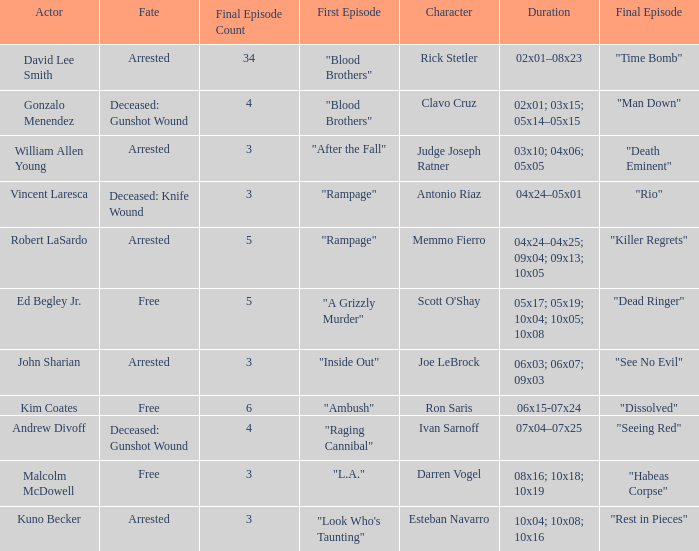Write the full table. {'header': ['Actor', 'Fate', 'Final Episode Count', 'First Episode', 'Character', 'Duration', 'Final Episode'], 'rows': [['David Lee Smith', 'Arrested', '34', '"Blood Brothers"', 'Rick Stetler', '02x01–08x23', '"Time Bomb"'], ['Gonzalo Menendez', 'Deceased: Gunshot Wound', '4', '"Blood Brothers"', 'Clavo Cruz', '02x01; 03x15; 05x14–05x15', '"Man Down"'], ['William Allen Young', 'Arrested', '3', '"After the Fall"', 'Judge Joseph Ratner', '03x10; 04x06; 05x05', '"Death Eminent"'], ['Vincent Laresca', 'Deceased: Knife Wound', '3', '"Rampage"', 'Antonio Riaz', '04x24–05x01', '"Rio"'], ['Robert LaSardo', 'Arrested', '5', '"Rampage"', 'Memmo Fierro', '04x24–04x25; 09x04; 09x13; 10x05', '"Killer Regrets"'], ['Ed Begley Jr.', 'Free', '5', '"A Grizzly Murder"', "Scott O'Shay", '05x17; 05x19; 10x04; 10x05; 10x08', '"Dead Ringer"'], ['John Sharian', 'Arrested', '3', '"Inside Out"', 'Joe LeBrock', '06x03; 06x07; 09x03', '"See No Evil"'], ['Kim Coates', 'Free', '6', '"Ambush"', 'Ron Saris', '06x15-07x24', '"Dissolved"'], ['Andrew Divoff', 'Deceased: Gunshot Wound', '4', '"Raging Cannibal"', 'Ivan Sarnoff', '07x04–07x25', '"Seeing Red"'], ['Malcolm McDowell', 'Free', '3', '"L.A."', 'Darren Vogel', '08x16; 10x18; 10x19', '"Habeas Corpse"'], ['Kuno Becker', 'Arrested', '3', '"Look Who\'s Taunting"', 'Esteban Navarro', '10x04; 10x08; 10x16', '"Rest in Pieces"']]} Which actor portrayed the character of judge joseph ratner? William Allen Young. 